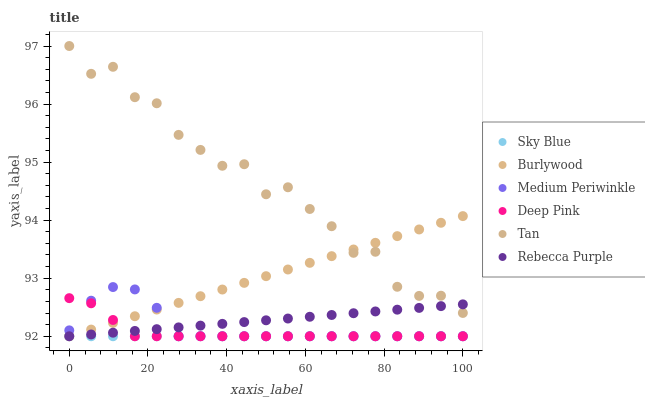Does Sky Blue have the minimum area under the curve?
Answer yes or no. Yes. Does Tan have the maximum area under the curve?
Answer yes or no. Yes. Does Burlywood have the minimum area under the curve?
Answer yes or no. No. Does Burlywood have the maximum area under the curve?
Answer yes or no. No. Is Rebecca Purple the smoothest?
Answer yes or no. Yes. Is Tan the roughest?
Answer yes or no. Yes. Is Burlywood the smoothest?
Answer yes or no. No. Is Burlywood the roughest?
Answer yes or no. No. Does Deep Pink have the lowest value?
Answer yes or no. Yes. Does Tan have the lowest value?
Answer yes or no. No. Does Tan have the highest value?
Answer yes or no. Yes. Does Burlywood have the highest value?
Answer yes or no. No. Is Medium Periwinkle less than Tan?
Answer yes or no. Yes. Is Tan greater than Deep Pink?
Answer yes or no. Yes. Does Deep Pink intersect Sky Blue?
Answer yes or no. Yes. Is Deep Pink less than Sky Blue?
Answer yes or no. No. Is Deep Pink greater than Sky Blue?
Answer yes or no. No. Does Medium Periwinkle intersect Tan?
Answer yes or no. No. 